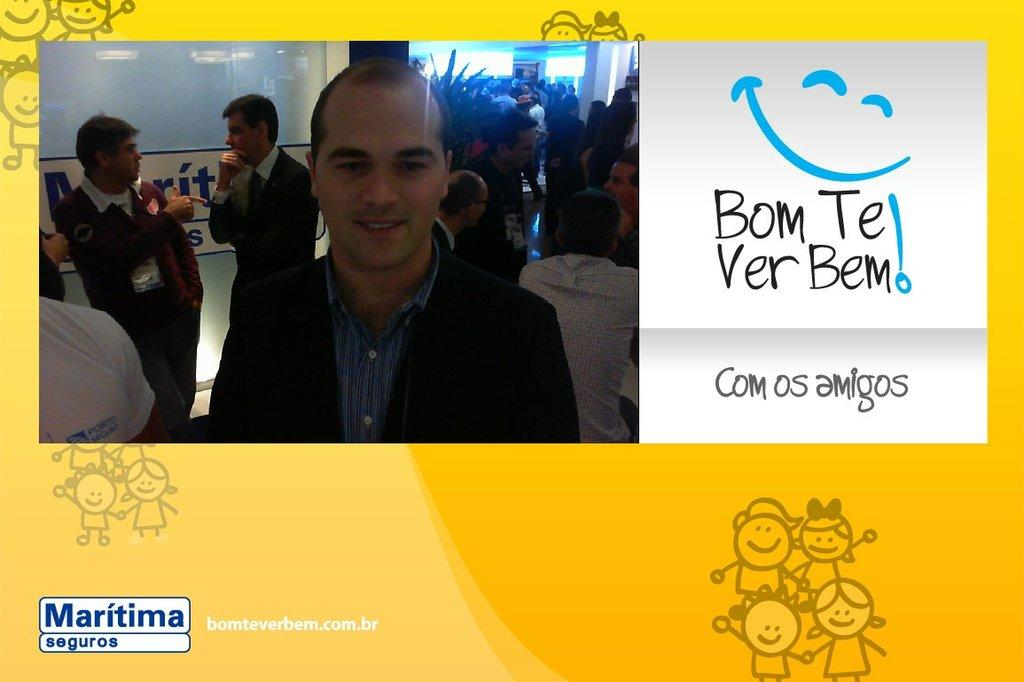What is the main subject of the image? The main subject of the image is a group of people standing. Are there any textual elements in the image? Yes, there are words in the image. Are there any non-textual elements in the image that are not people? Yes, there are symbols in the image. What type of animal can be seen sitting on the sofa in the image? There is no sofa or animal present in the image. 